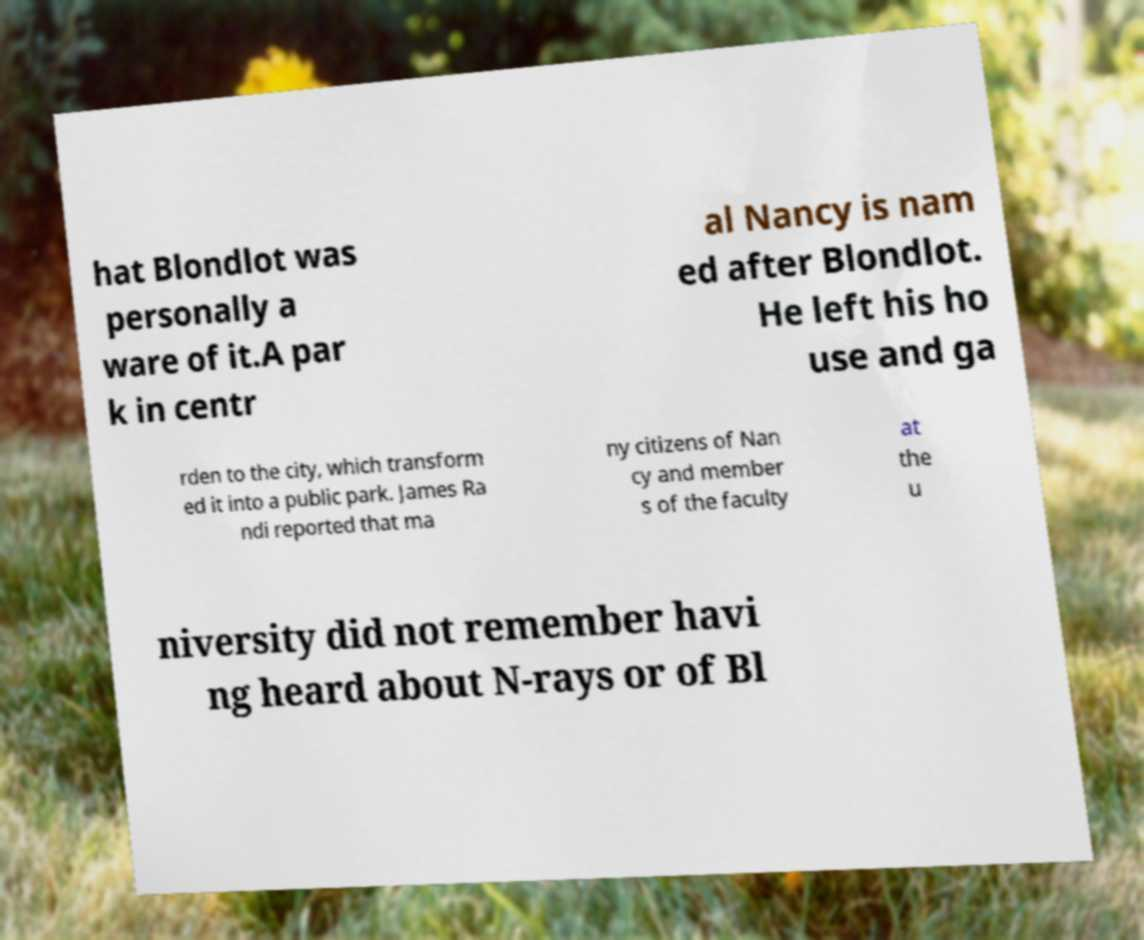There's text embedded in this image that I need extracted. Can you transcribe it verbatim? hat Blondlot was personally a ware of it.A par k in centr al Nancy is nam ed after Blondlot. He left his ho use and ga rden to the city, which transform ed it into a public park. James Ra ndi reported that ma ny citizens of Nan cy and member s of the faculty at the u niversity did not remember havi ng heard about N-rays or of Bl 